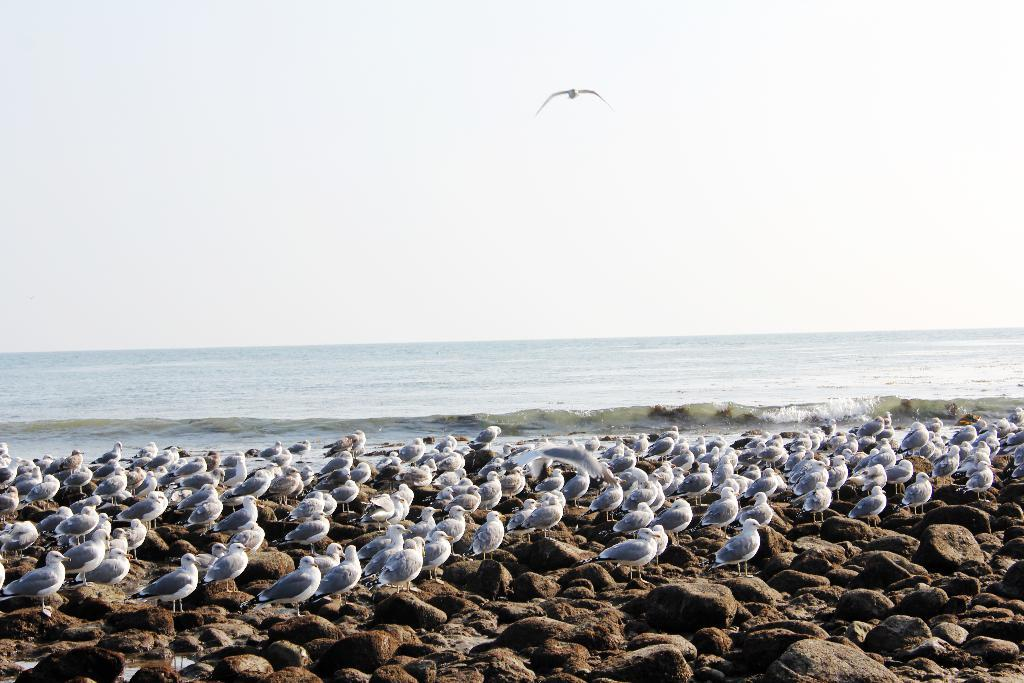What is on the ground in the image? There is a group of birds on the ground in the image. What is happening in the sky in the background of the image? There is a bird flying in the sky in the background of the image. What can be seen in the distance in the image? There is water visible in the background of the image. What type of fear does the coach have in the image? There is no coach present in the image, so it is not possible to determine if they have any fear. 